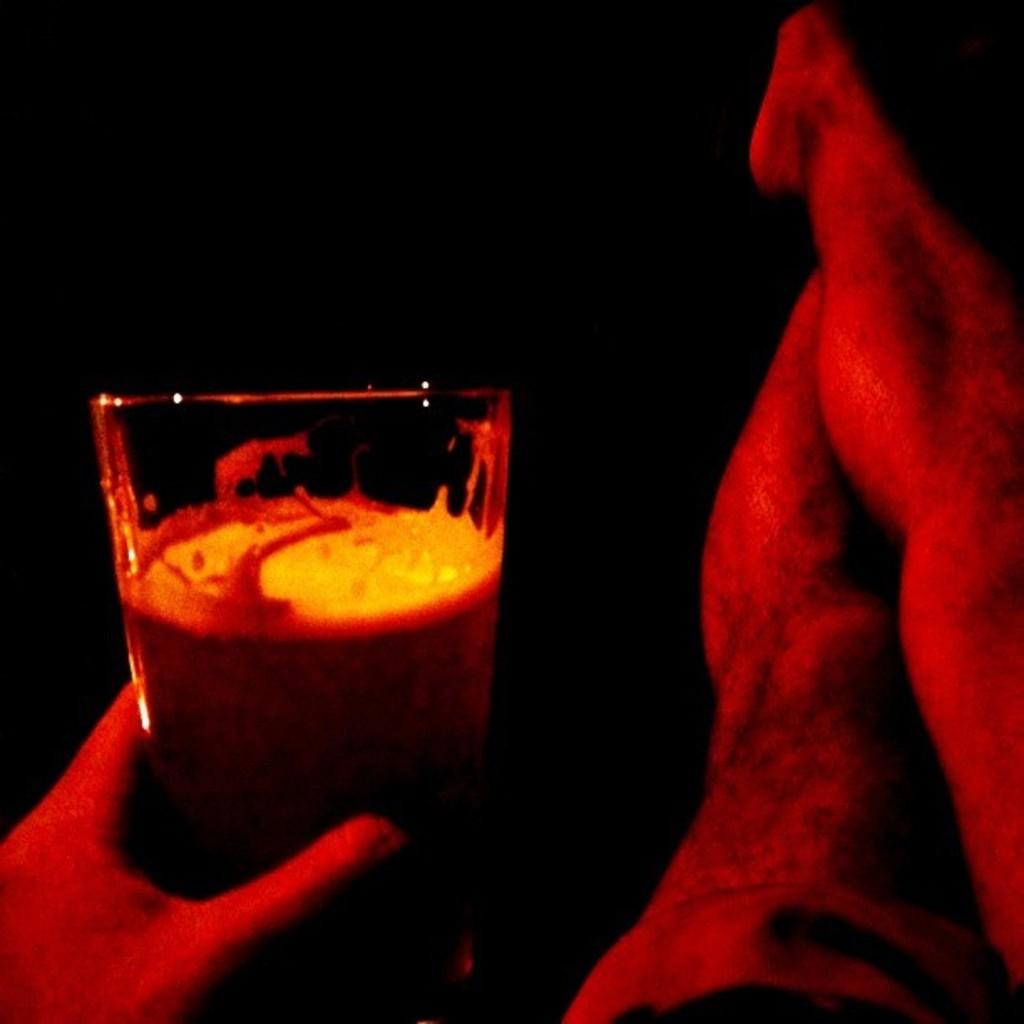What can be seen on the right side of the image? There are legs of a person in the foreground of the image. Where is the hand holding a glass located in the image? The hand is on the left side of the image. Can you describe the position of the legs and hand in relation to each other? The legs are on the right side of the image, while the hand is on the left side. What type of steel is visible in the pocket of the person in the image? There is no steel or pocket visible in the image; it only shows legs and a hand. 